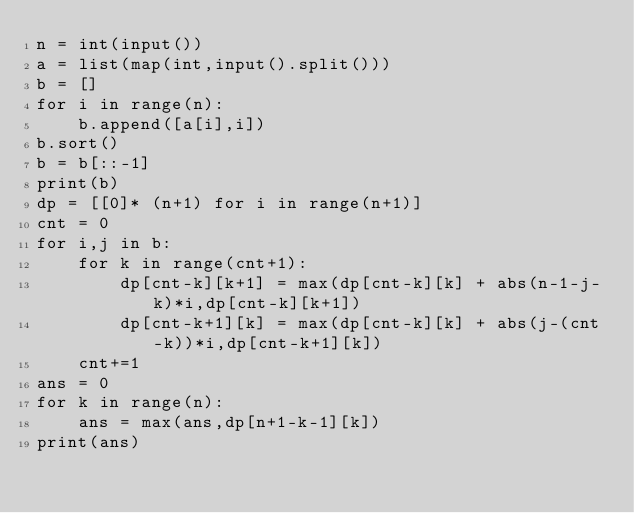<code> <loc_0><loc_0><loc_500><loc_500><_Python_>n = int(input())
a = list(map(int,input().split()))
b = []
for i in range(n):
    b.append([a[i],i])
b.sort()
b = b[::-1]
print(b)
dp = [[0]* (n+1) for i in range(n+1)]
cnt = 0
for i,j in b:
    for k in range(cnt+1):
        dp[cnt-k][k+1] = max(dp[cnt-k][k] + abs(n-1-j-k)*i,dp[cnt-k][k+1])
        dp[cnt-k+1][k] = max(dp[cnt-k][k] + abs(j-(cnt-k))*i,dp[cnt-k+1][k])
    cnt+=1
ans = 0
for k in range(n):
    ans = max(ans,dp[n+1-k-1][k])
print(ans)</code> 